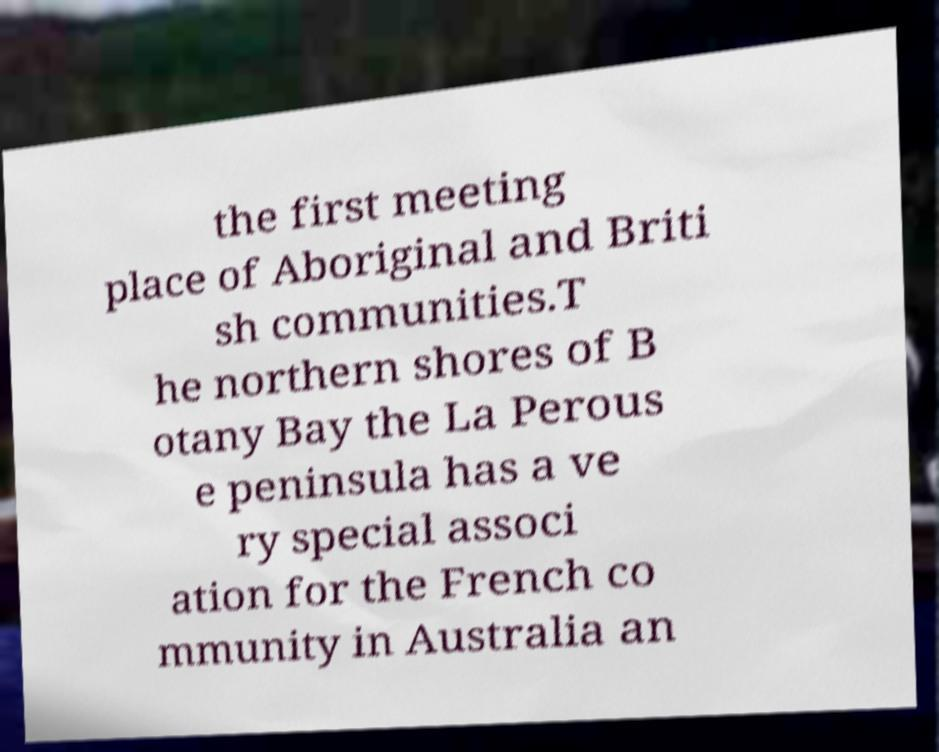Please identify and transcribe the text found in this image. the first meeting place of Aboriginal and Briti sh communities.T he northern shores of B otany Bay the La Perous e peninsula has a ve ry special associ ation for the French co mmunity in Australia an 